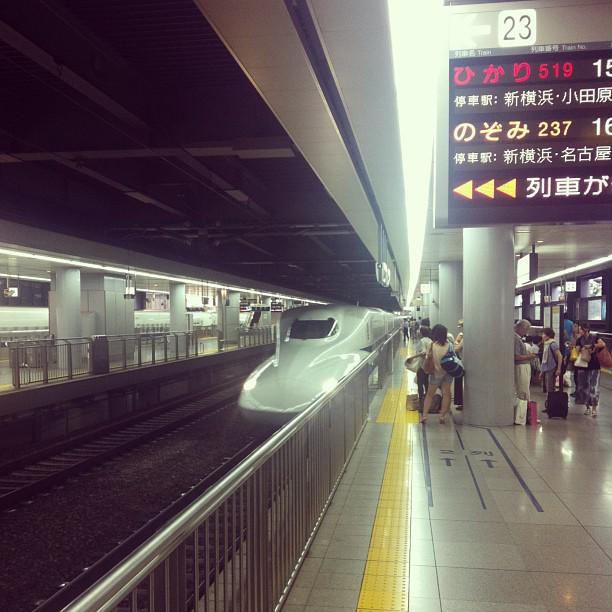Question: what is Asian?
Choices:
A. Writing in a book.
B. Subtitles on a movie.
C. Writing on sign.
D. Tourists in a bus.
Answer with the letter. Answer: C Question: what is yellow?
Choices:
A. Line on floor.
B. School bus.
C. Sailboat.
D. Banana.
Answer with the letter. Answer: A Question: what kind of country is it?
Choices:
A. Italian.
B. Asian.
C. Greek.
D. French.
Answer with the letter. Answer: B Question: why are the people there?
Choices:
A. Waiting for a bus.
B. To catch a train.
C. Enjoying the sunshine.
D. Eating lunch.
Answer with the letter. Answer: B Question: what is on the sign?
Choices:
A. Writing in a foreign language.
B. The speed limit.
C. The store's hours of operation.
D. The name of the store.
Answer with the letter. Answer: A Question: who is waiting for the trains?
Choices:
A. A lady and her son.
B. Many people.
C. The man with a mustache.
D. The lady wearing a red hat.
Answer with the letter. Answer: B Question: what number is on the sign?
Choices:
A. 55.
B. 23.
C. 65.
D. 15.
Answer with the letter. Answer: B Question: where are the passengers?
Choices:
A. On a plain.
B. In a car.
C. On a bus.
D. Inside the train station.
Answer with the letter. Answer: D Question: what is on?
Choices:
A. Television.
B. Computer.
C. Train headlights.
D. Phone.
Answer with the letter. Answer: C Question: what color are the arrows?
Choices:
A. Yellow.
B. Green.
C. Black.
D. Blue.
Answer with the letter. Answer: A Question: what number is on the sign?
Choices:
A. 23.
B. 17.
C. 12.
D. 30.
Answer with the letter. Answer: A Question: what is the train nose like?
Choices:
A. Aerodynamic.
B. A bullet.
C. A missile.
D. A cucumber.
Answer with the letter. Answer: A Question: who wears a white scarf with a black suitcase?
Choices:
A. The man.
B. The business man.
C. The elderly lady.
D. A woman.
Answer with the letter. Answer: D Question: what language is the letters in?
Choices:
A. Arabic.
B. German.
C. Afrikaans.
D. Asian.
Answer with the letter. Answer: D Question: what is white?
Choices:
A. Car.
B. Train.
C. House.
D. Truck.
Answer with the letter. Answer: B 